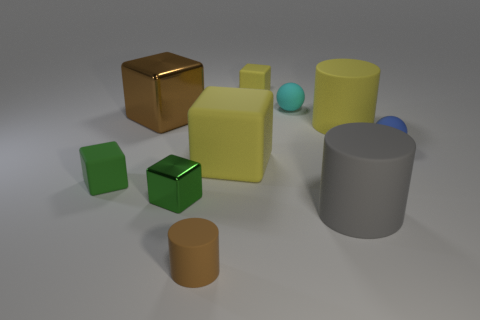How many green blocks must be subtracted to get 1 green blocks? 1 Subtract all green cubes. How many cubes are left? 3 Subtract all green blocks. How many blocks are left? 3 Add 4 yellow matte objects. How many yellow matte objects are left? 7 Add 1 tiny cyan spheres. How many tiny cyan spheres exist? 2 Subtract 1 gray cylinders. How many objects are left? 9 Subtract all cylinders. How many objects are left? 7 Subtract 5 blocks. How many blocks are left? 0 Subtract all yellow balls. Subtract all blue cylinders. How many balls are left? 2 Subtract all brown blocks. How many gray balls are left? 0 